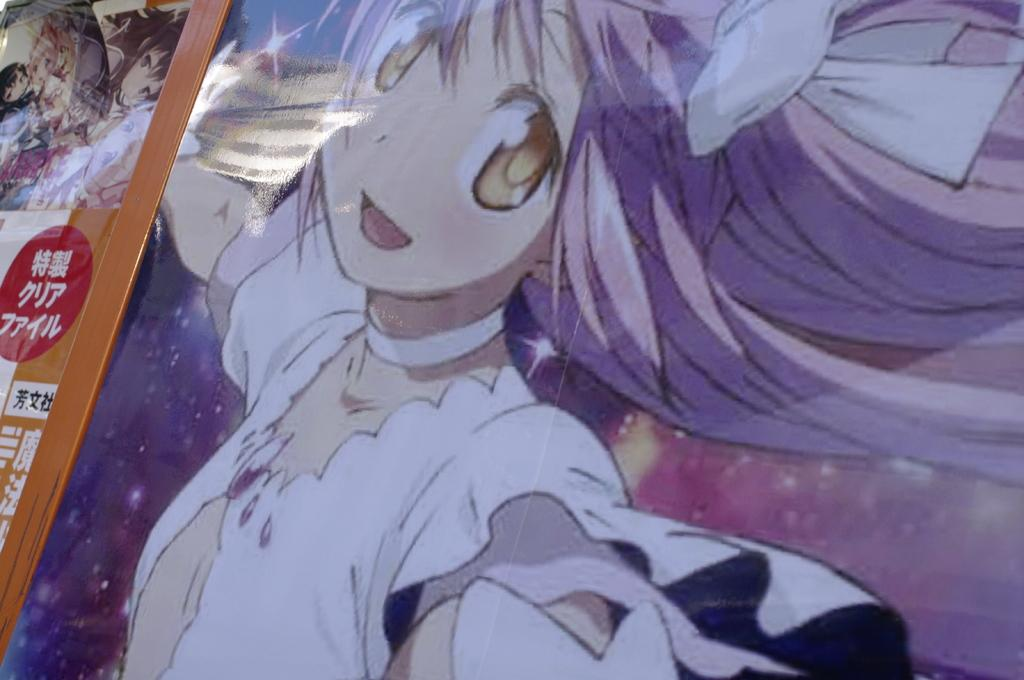What is the main subject of the hoarding in the image? The hoarding contains a painting with an animated image of a person. What can be seen in the background of the painting on the hoarding? There are stars in the background of the hoarding. What is located on the left side of the image? There is a poster on the left side of the image. What type of creature is shown interacting with the stars in the image? There is no creature shown interacting with the stars in the image; the stars are part of the background of the painting on the hoarding. 